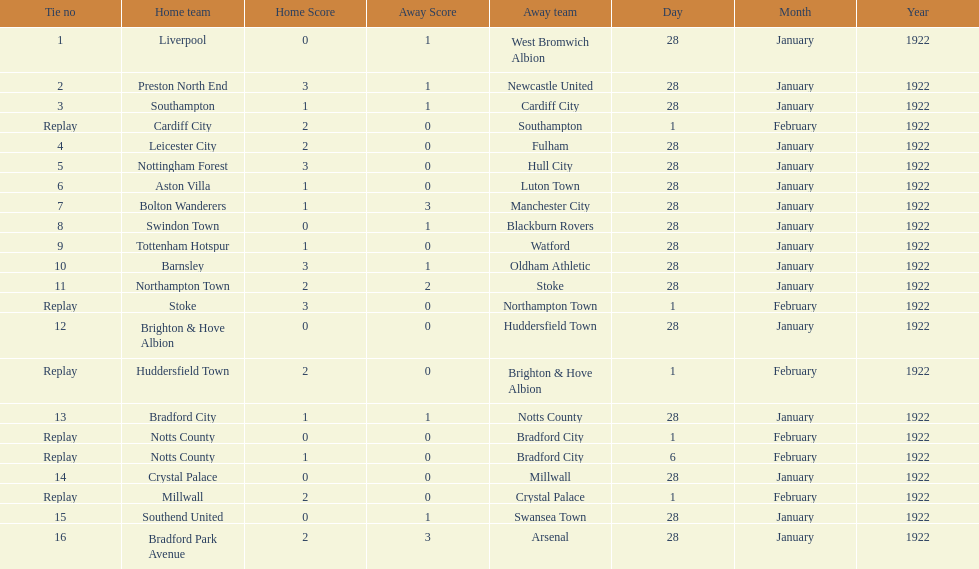How many games had no points scored? 3. 